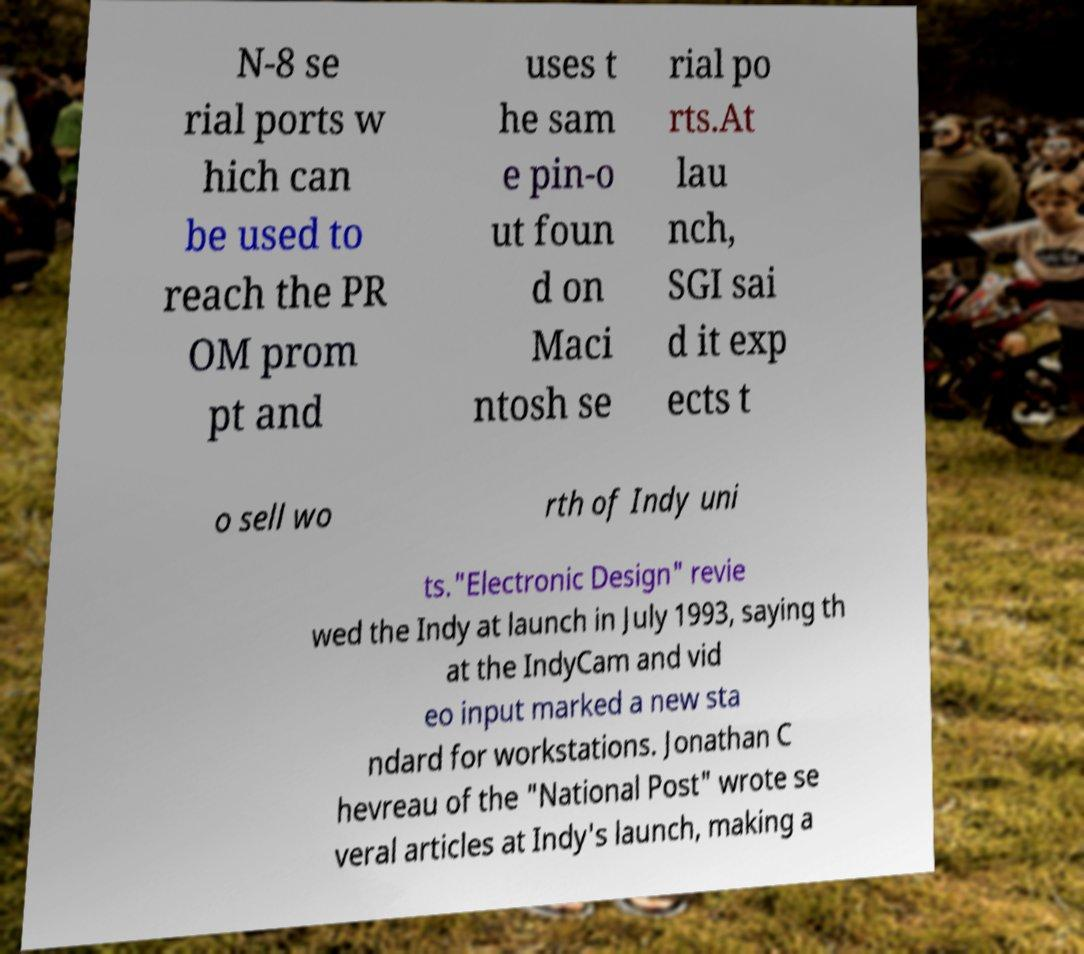There's text embedded in this image that I need extracted. Can you transcribe it verbatim? N-8 se rial ports w hich can be used to reach the PR OM prom pt and uses t he sam e pin-o ut foun d on Maci ntosh se rial po rts.At lau nch, SGI sai d it exp ects t o sell wo rth of Indy uni ts."Electronic Design" revie wed the Indy at launch in July 1993, saying th at the IndyCam and vid eo input marked a new sta ndard for workstations. Jonathan C hevreau of the "National Post" wrote se veral articles at Indy's launch, making a 